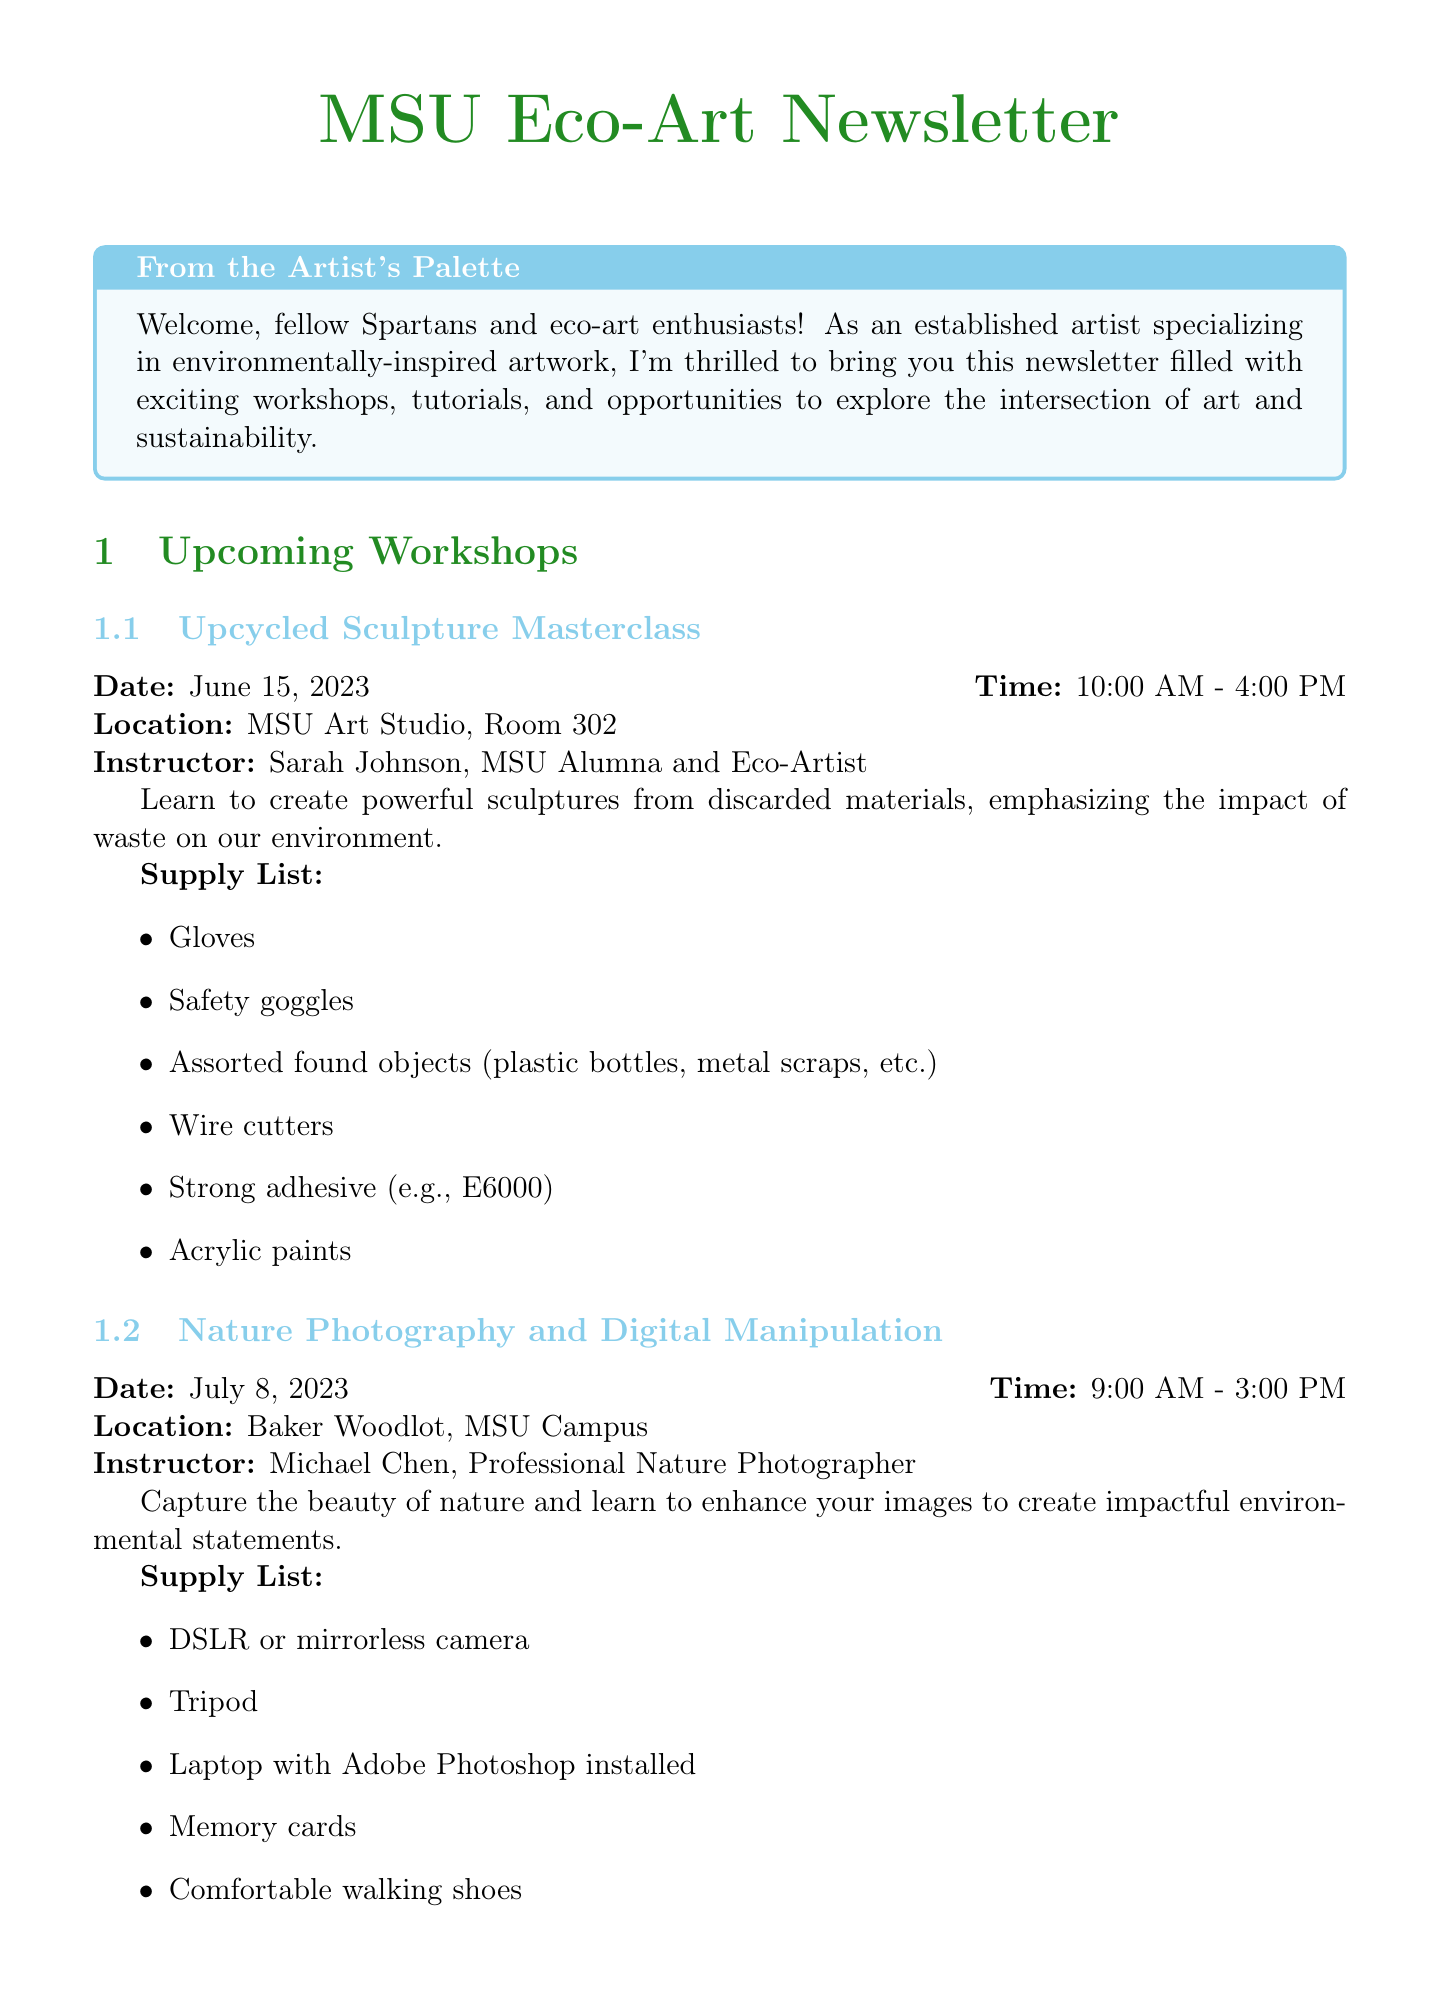What is the date of the Upcycled Sculpture Masterclass? The date is specified in the workshop details for the Upcycled Sculpture Masterclass.
Answer: June 15, 2023 Who is the instructor for the Eco-Friendly Printmaking Techniques workshop? The document lists the instructor specifically for each workshop.
Answer: Emily Watson, Printmaking Expert and Environmental Advocate What materials are needed for the featured tutorial on Creating Biodegradable Land Art? The materials list is found under the featured tutorial section of the newsletter.
Answer: Sketchbook and pencils, Gardening gloves, Biodegradable twine, Camera or smartphone, Reusable water bottle What is the location for the Nature Photography and Digital Manipulation workshop? The location is provided in the workshop details for the Nature Photography and Digital Manipulation event.
Answer: Baker Woodlot, MSU Campus What is the submission deadline for the Spartan Green: MSU Alumni Eco-Art Showcase? The submission deadline is given in the exhibition details section of the newsletter.
Answer: August 15, 2023 How long is the community project event on October 7, 2023? The duration is indicated in the community project section mentioning the start and end times.
Answer: 6 hours What is the main focus of the workshops mentioned in the newsletter? The document provides a clear focus for each workshop, highlighting their environmental themes.
Answer: Environmentally-inspired artwork How many eco-art workshops are listed in the document? The number of workshops can be counted from the workshop calendar provided.
Answer: Three 